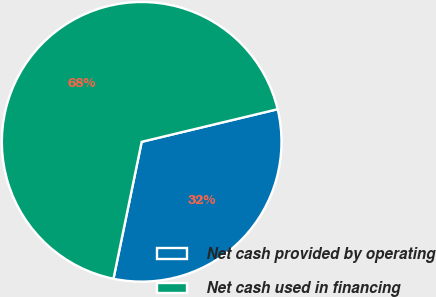Convert chart. <chart><loc_0><loc_0><loc_500><loc_500><pie_chart><fcel>Net cash provided by operating<fcel>Net cash used in financing<nl><fcel>31.98%<fcel>68.02%<nl></chart> 